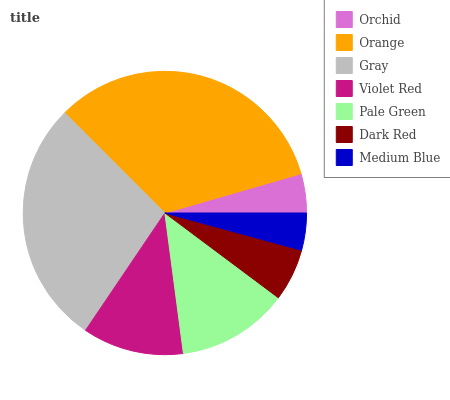Is Medium Blue the minimum?
Answer yes or no. Yes. Is Orange the maximum?
Answer yes or no. Yes. Is Gray the minimum?
Answer yes or no. No. Is Gray the maximum?
Answer yes or no. No. Is Orange greater than Gray?
Answer yes or no. Yes. Is Gray less than Orange?
Answer yes or no. Yes. Is Gray greater than Orange?
Answer yes or no. No. Is Orange less than Gray?
Answer yes or no. No. Is Violet Red the high median?
Answer yes or no. Yes. Is Violet Red the low median?
Answer yes or no. Yes. Is Dark Red the high median?
Answer yes or no. No. Is Orchid the low median?
Answer yes or no. No. 